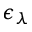Convert formula to latex. <formula><loc_0><loc_0><loc_500><loc_500>\epsilon _ { \lambda }</formula> 